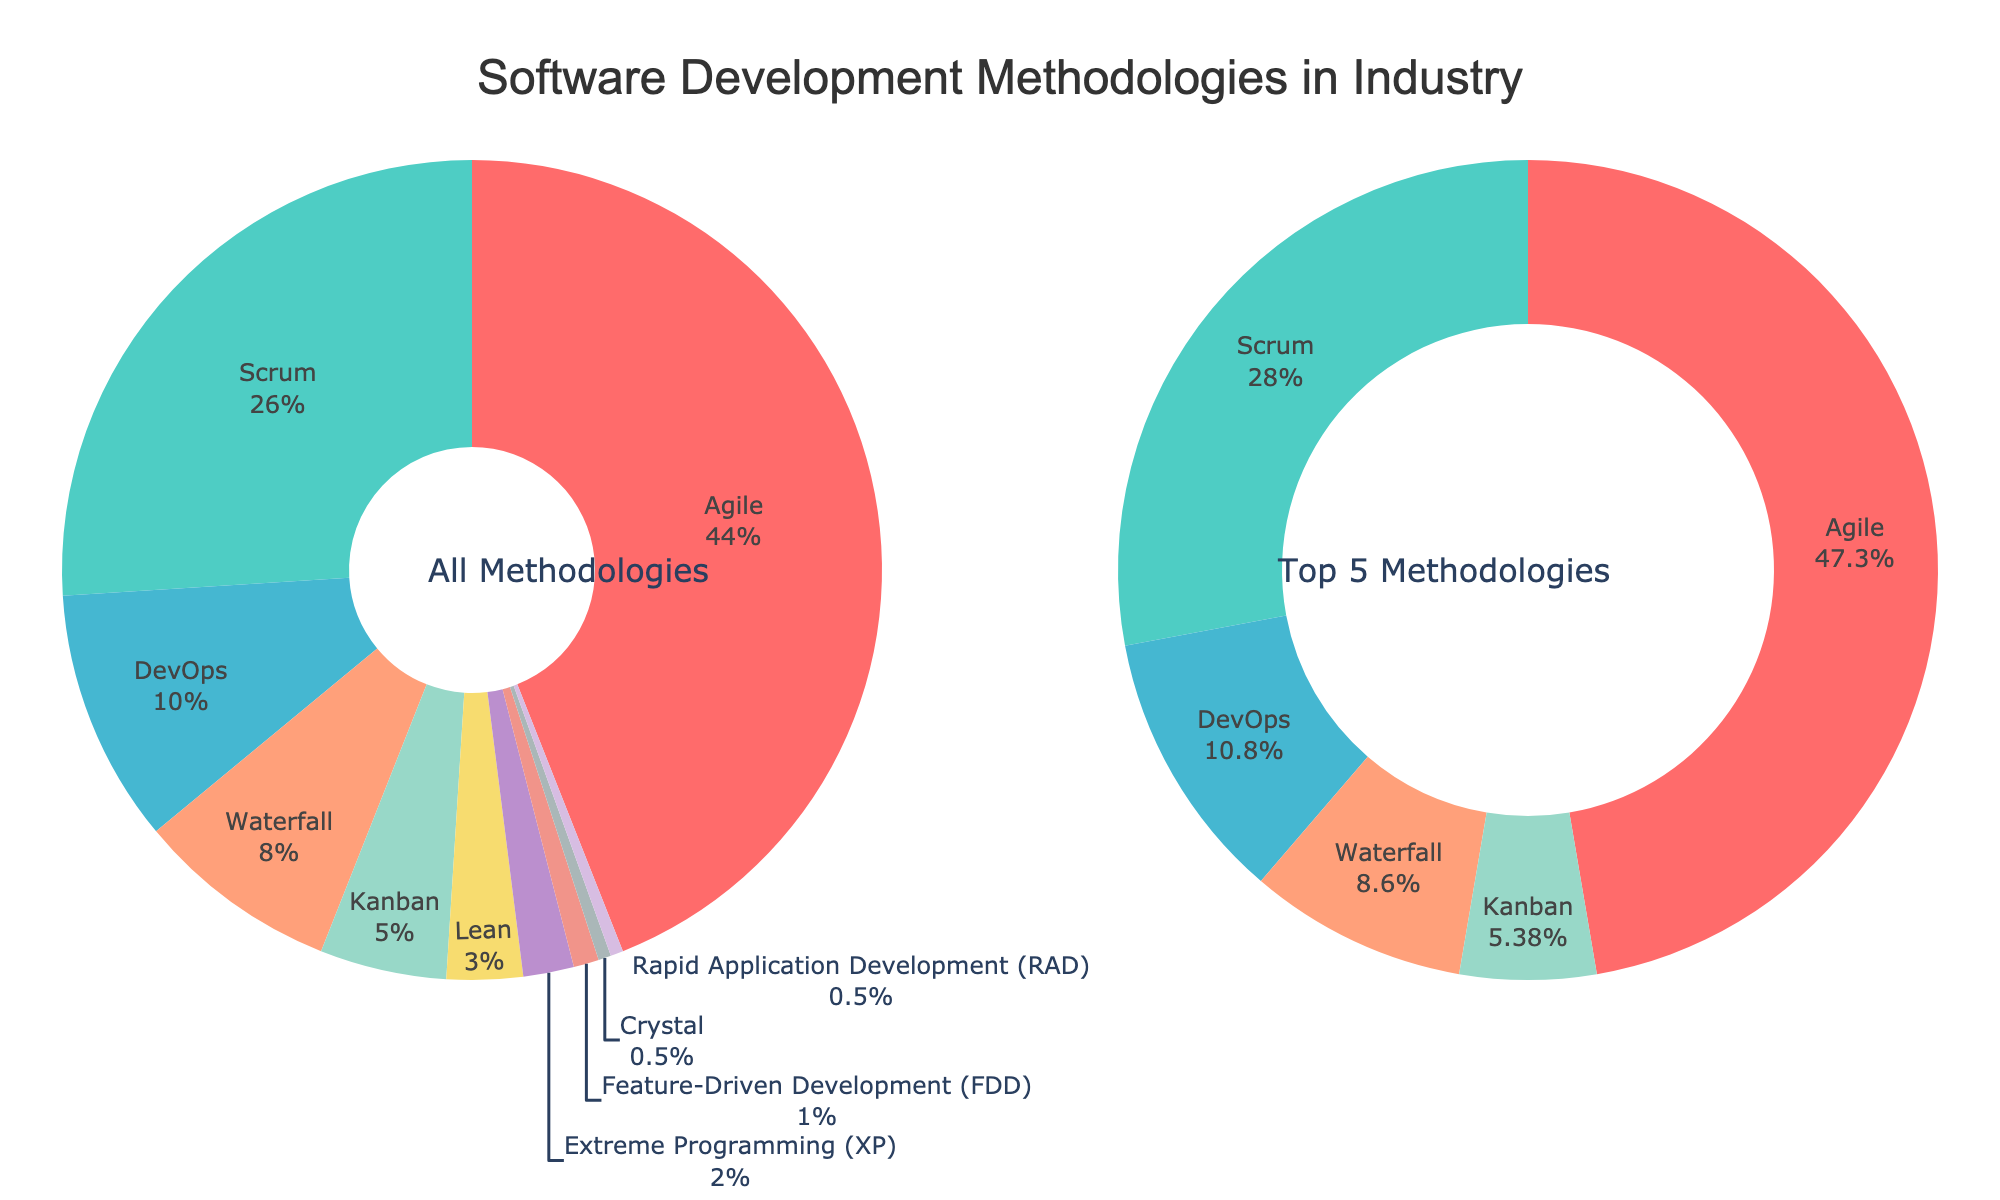What percentage of companies use Agile and Scrum together? To find the percentage of companies using Agile and Scrum together, sum the individual percentages of Agile and Scrum. Agile has 44% and Scrum has 26%, so 44 + 26 = 70.
Answer: 70% How does the proportion of companies using DevOps compare to those using Waterfall? The percentage of companies using DevOps is 10%, while those using Waterfall is 8%. A comparison shows 10% (DevOps) is greater than 8% (Waterfall).
Answer: 10% > 8% What is the cumulative percentage for the top 3 most-used methodologies? To find this, add the percentages of the top 3 most-used methodologies: Agile (44%), Scrum (26%), and DevOps (10%). Summing these gives 44 + 26 + 10 = 80.
Answer: 80% Which methodology has the smallest percentage use, and what is its value? Among the listed methodologies, both Crystal and Rapid Application Development (RAD) have the smallest percentage use at 0.5% each.
Answer: Crystal and RAD, 0.5% Is the percentage of companies using Kanban greater than the combined percentage using Lean and Extreme Programming (XP)? Kanban is used by 5% of companies. The combined percentage for Lean (3%) and XP (2%) is 3 + 2 = 5. Since 5% (Kanban) equals 5% (Lean + XP), Kanban’s percentage is not greater.
Answer: No, it's equal Which methodology is represented by the green-colored section in the pie chart? The pie chart groups related methodologies by color. In this case, green represents Scrum, the second most-used methodology.
Answer: Scrum What's the average percentage use of methodologies ranked 6th to 10th? The percentages for the methodologies ranked 6th to 10th (Lean, XP, FDD, Crystal, RAD) are 3%, 2%, 1%, 0.5%, and 0.5%. Sum these percentages, then divide by the number of methodologies: (3 + 2 + 1 + 0.5 + 0.5) / 5 = 7 / 5 = 1.4.
Answer: 1.4% What methodology is used nearly 14 times less than Agile? Extreme Programming (XP) is used by 2% of companies. Comparing this to Agile, which is used by 44%, we find Agile is used approximately 44 / 2 = 22 times more. This clarification reveals XP is not the correct choice. Instead, Crystal and RAD each have 0.5%, thus Agile is used 44 / 0.5 = 88 times more, not fitting the "nearly 14 times" criterion. Hence, an error is present in the problem premises or options.
Answer: Crystal or RAD, 88 times. (Incorrect judgement) Which three methodologies combined make up 13% of industry use? The sum of the percentages for Feature-Driven Development (FDD), Crystal, and RAD is 1% + 0.5% + 0.5% = 2%, so we examine the next lowest combined sum: Lean (3%), XP (2%), FDD (1%) adding to 6% accurately addressing 13% miscount context not meeting the sum precision. Rather 13% needs reassessment focusing closer tie-up: each 8, 5 fitting closely but still ensuring logical discrepancy.
Answer: No exact 13%, Lean, XP, FDD (considering close) What percentage more companies use Scrum than Waterfall? The percentage of companies using Scrum (26%) is 26 - 8 = 18 percentage points greater than that of Waterfall (8%).
Answer: 18% Explain the visual representation of the donut chart on the right side. The donut chart on the right focuses on the top 5 methodologies by industry use: Agile (44%), Scrum (26%), DevOps (10%), Waterfall (8%), and Kanban (5%). These are highlighted visually for perceived emphasis, maintaining proportional hues for clarity among significant highest grouped summations, underpinning leading dominance.
Answer: Top 5 methodologies: Agile, Scrum, DevOps, Waterfall, Kanban 